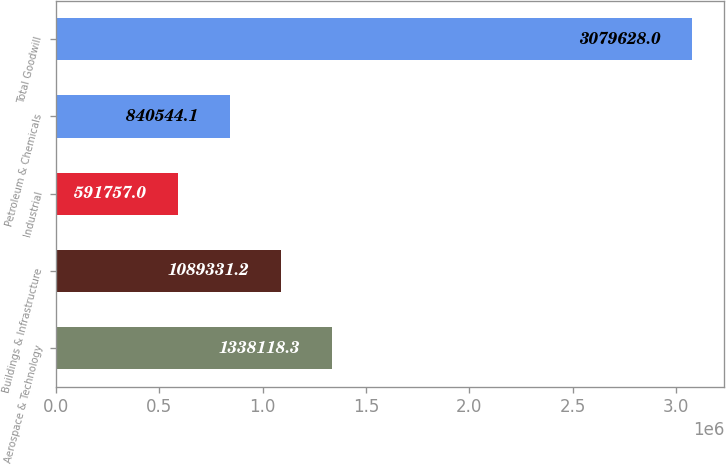Convert chart. <chart><loc_0><loc_0><loc_500><loc_500><bar_chart><fcel>Aerospace & Technology<fcel>Buildings & Infrastructure<fcel>Industrial<fcel>Petroleum & Chemicals<fcel>Total Goodwill<nl><fcel>1.33812e+06<fcel>1.08933e+06<fcel>591757<fcel>840544<fcel>3.07963e+06<nl></chart> 